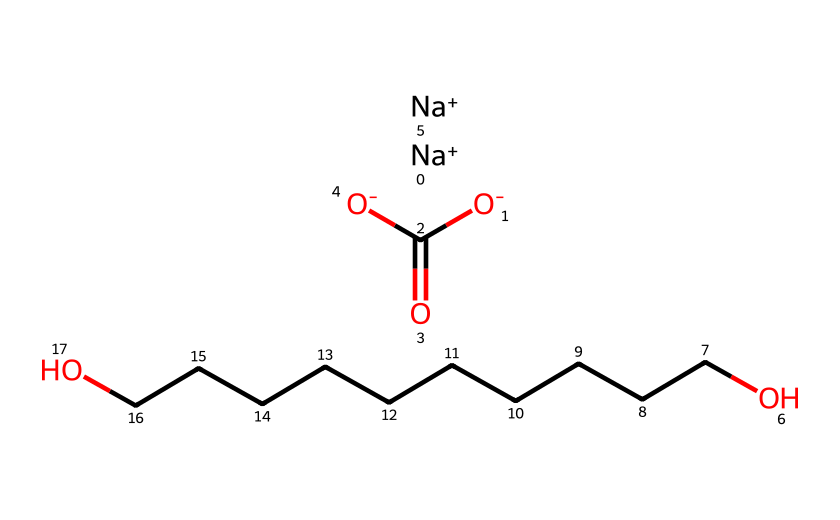What elements are present in this chemical? By analyzing the SMILES representation, we can identify the elemental composition: Sodium (Na), Carbon (C), Oxygen (O), and Hydrogen (H) are all present. The presence of these symbols confirms their inclusion in the chemical structure.
Answer: Sodium, Carbon, Oxygen, Hydrogen How many carbon atoms are in this structure? The chemical structure includes two representations of Carbon (C), totaling to 5 carbon atoms in the overall chemical composition as observed in the SMILES structure.
Answer: 5 What type of chemical compound is represented here? This structure is indicative of a detergent, as it contains both polar (ionic) and non-polar (alkyl chain) components, which is characteristic of surfactants used in cleaning.
Answer: detergent What is the charge on the sodium ions? The SMILES notation includes "[Na+]" which denotes that the sodium ions have a positive charge of +1.
Answer: +1 How many sodium ions are present in the structure? The SMILES representation shows two instances of "[Na+]", indicating that there are two sodium ions present in the chemical structure.
Answer: 2 Which part of this chemical is responsible for its detergent properties? The long hydrocarbon chain (represented by "OCCCCCCCCCCO") contributes to the hydrophobic properties, while the ionic parts provide hydrophilicity, essential for detergent function.
Answer: hydrocarbon chain 